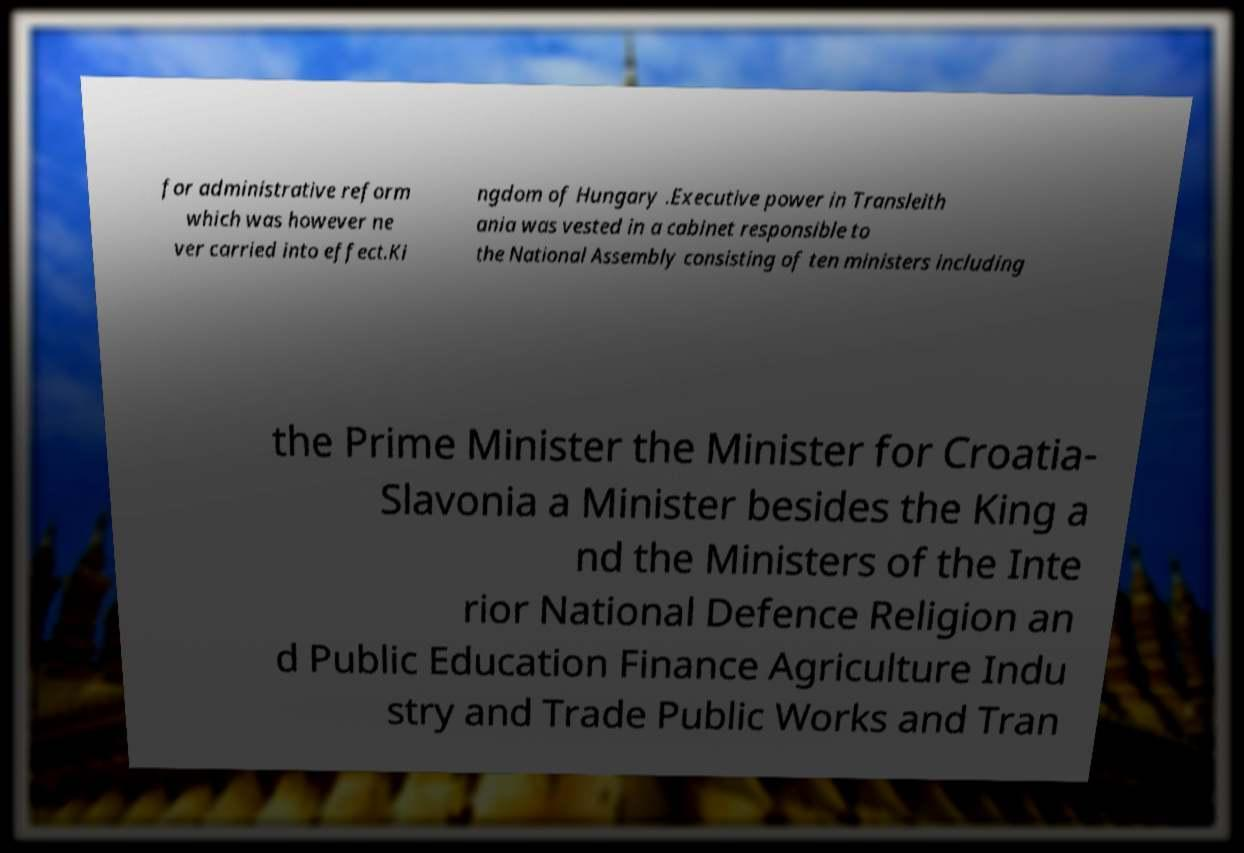Can you accurately transcribe the text from the provided image for me? for administrative reform which was however ne ver carried into effect.Ki ngdom of Hungary .Executive power in Transleith ania was vested in a cabinet responsible to the National Assembly consisting of ten ministers including the Prime Minister the Minister for Croatia- Slavonia a Minister besides the King a nd the Ministers of the Inte rior National Defence Religion an d Public Education Finance Agriculture Indu stry and Trade Public Works and Tran 